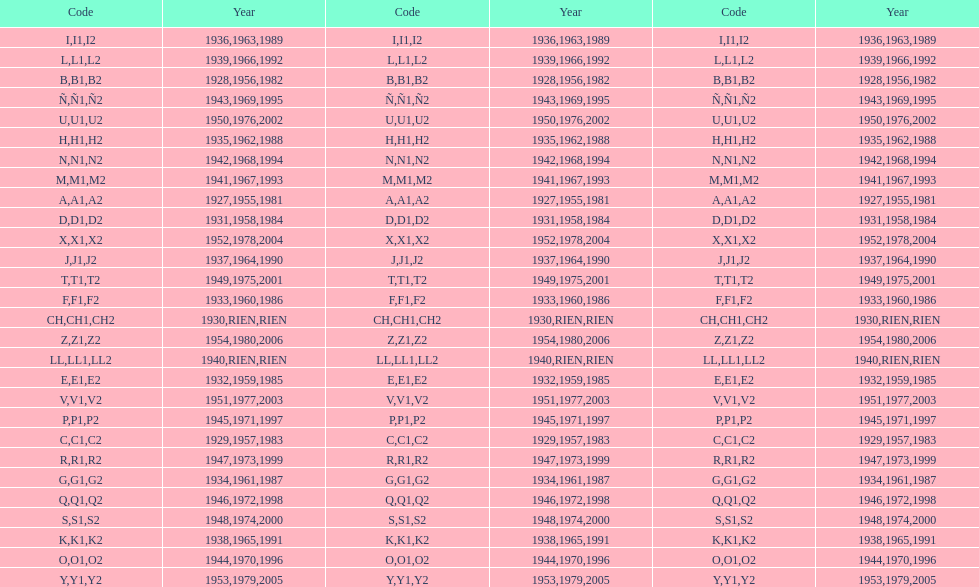How many different codes were used from 1953 to 1958? 6. 